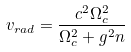Convert formula to latex. <formula><loc_0><loc_0><loc_500><loc_500>v _ { r a d } = \frac { c ^ { 2 } \Omega _ { c } ^ { 2 } } { \Omega _ { c } ^ { 2 } + g ^ { 2 } n }</formula> 